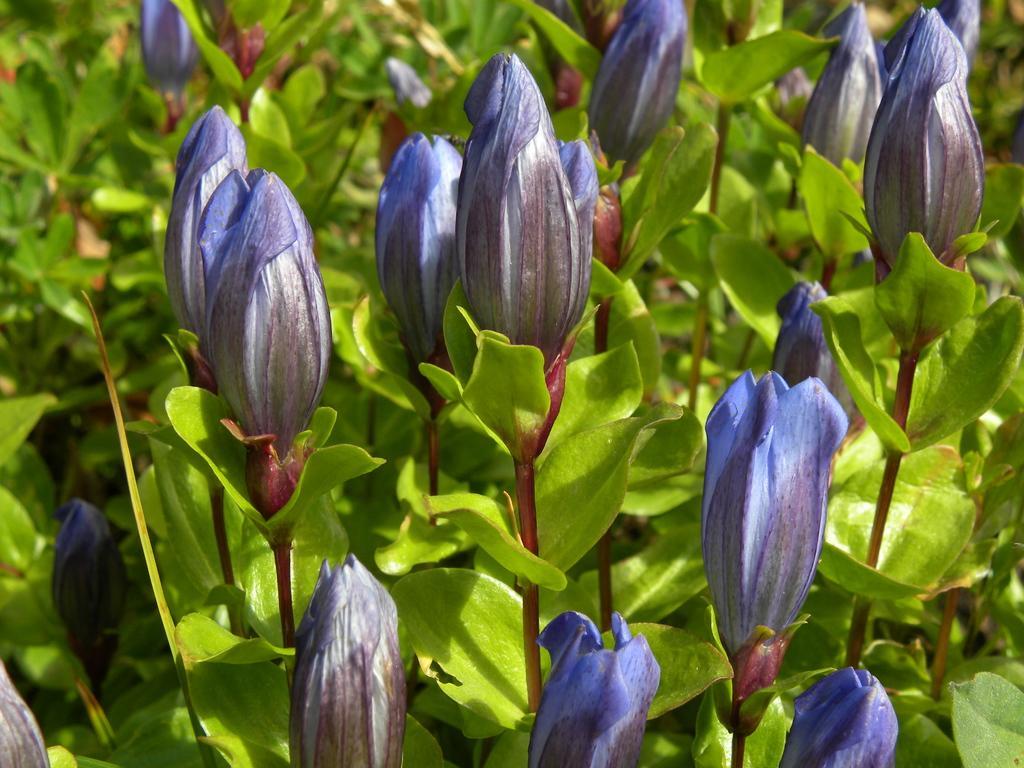Could you give a brief overview of what you see in this image? In this image there are plants for that plants there are flowers. 